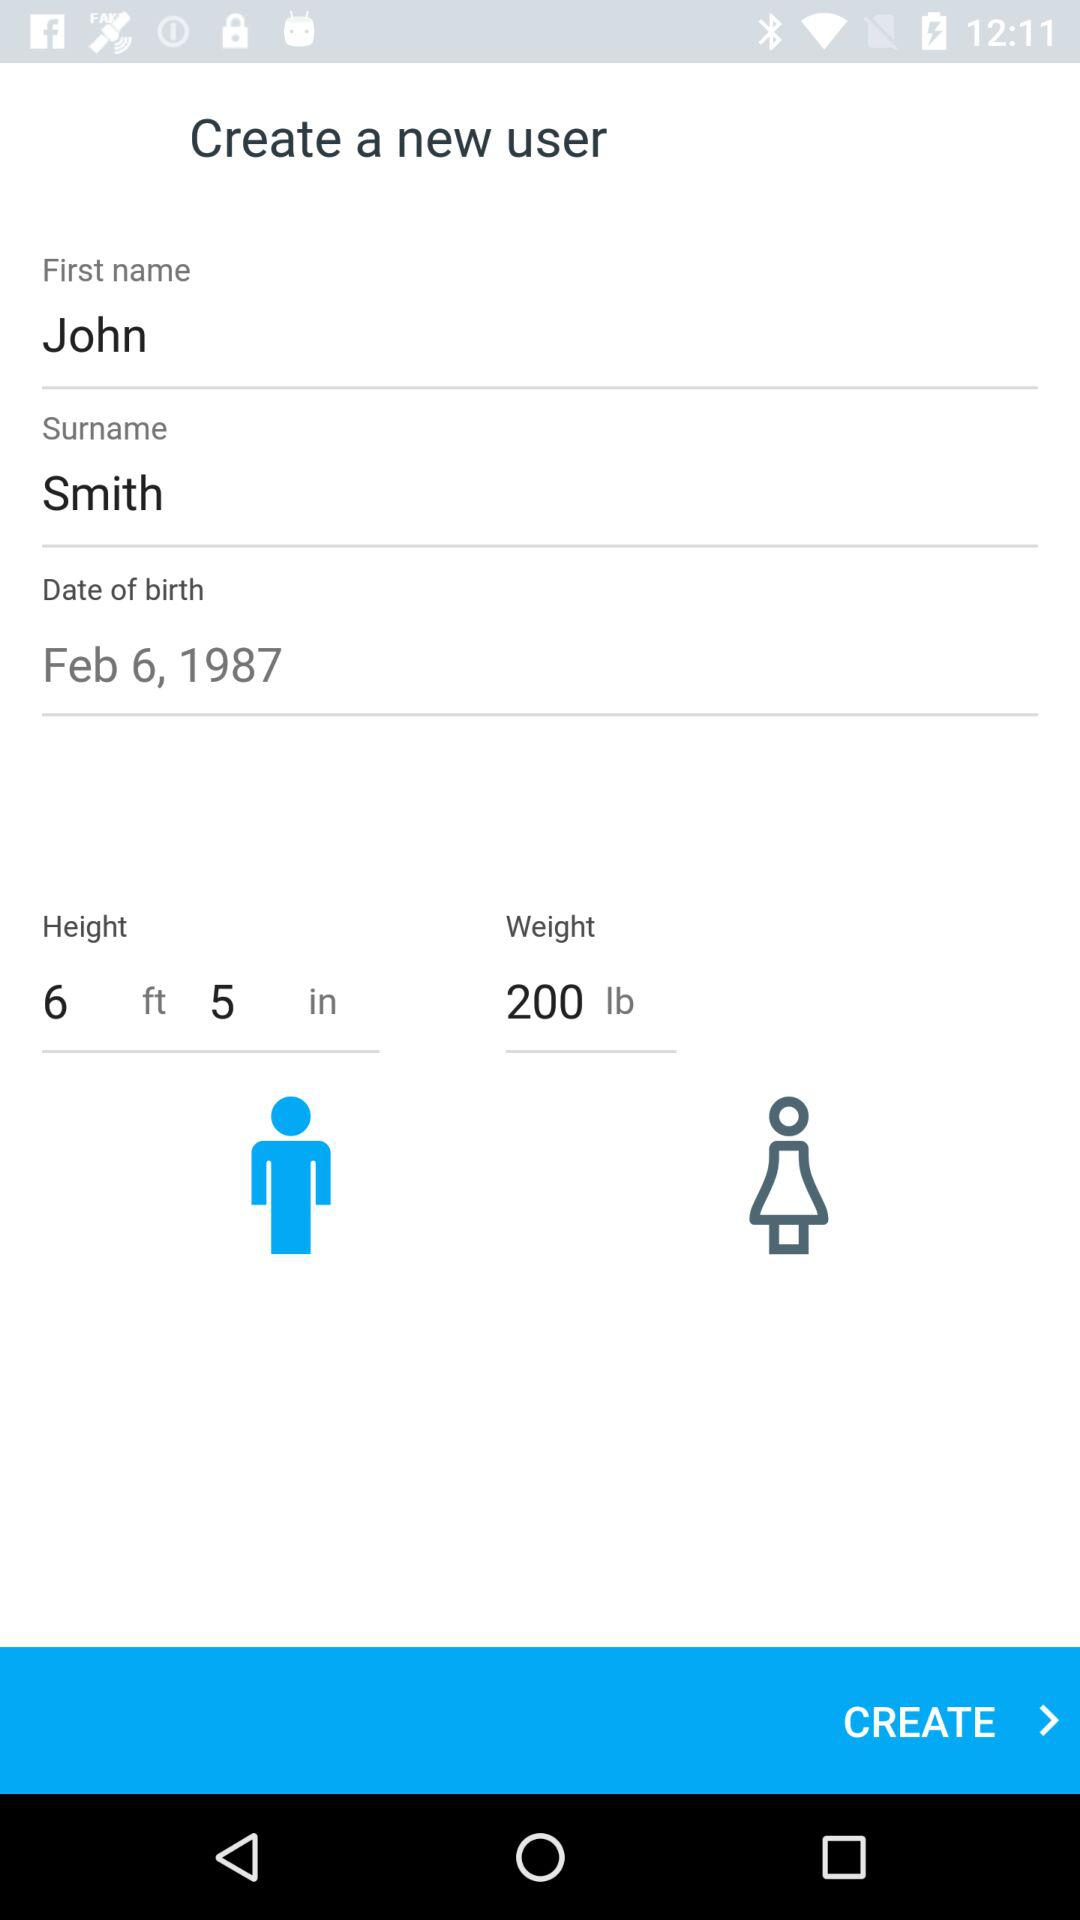How many text inputs are in the first section?
Answer the question using a single word or phrase. 3 